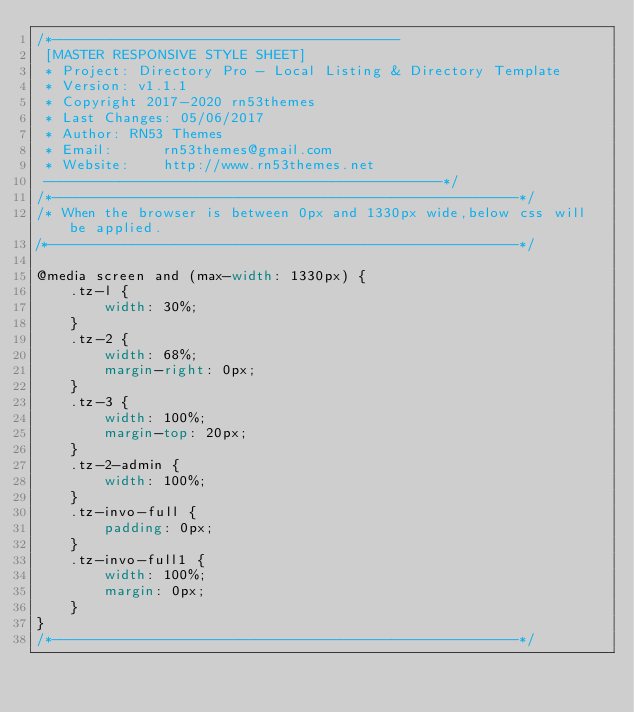Convert code to text. <code><loc_0><loc_0><loc_500><loc_500><_CSS_>/*-----------------------------------------
 [MASTER RESPONSIVE STYLE SHEET]
 * Project: Directory Pro - Local Listing & Directory Template
 * Version: v1.1.1
 * Copyright 2017-2020 rn53themes
 * Last Changes: 05/06/2017
 * Author: RN53 Themes
 * Email:      rn53themes@gmail.com
 * Website:    http://www.rn53themes.net 
 -----------------------------------------------*/
/*-------------------------------------------------------*/
/* When the browser is between 0px and 1330px wide,below css will be applied.
/*-------------------------------------------------------*/

@media screen and (max-width: 1330px) {
    .tz-l {
        width: 30%;
    }
    .tz-2 {
        width: 68%;
        margin-right: 0px;
    }
    .tz-3 {
        width: 100%;
        margin-top: 20px;
    }
    .tz-2-admin {
        width: 100%;
    }
    .tz-invo-full {
        padding: 0px;
    }
    .tz-invo-full1 {
        width: 100%;
        margin: 0px;
    }
}
/*-------------------------------------------------------*/</code> 